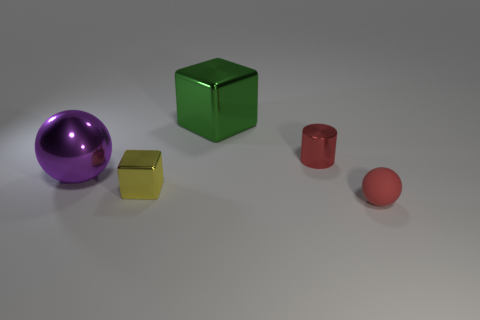Does the green cube have the same material as the ball that is on the left side of the big green shiny cube?
Ensure brevity in your answer.  Yes. What is the object that is both left of the green cube and behind the tiny yellow thing made of?
Your response must be concise. Metal. There is a block in front of the tiny red thing behind the red ball; what is its color?
Your answer should be compact. Yellow. There is a large thing on the left side of the big green object; what material is it?
Your answer should be very brief. Metal. Is the number of large metal objects less than the number of big blue blocks?
Your answer should be compact. No. There is a yellow object; is its shape the same as the red thing that is behind the small sphere?
Offer a very short reply. No. There is a metal object that is both in front of the tiny cylinder and to the right of the big purple sphere; what is its shape?
Ensure brevity in your answer.  Cube. Are there an equal number of tiny metal cylinders that are right of the red cylinder and red shiny objects that are to the left of the tiny yellow block?
Ensure brevity in your answer.  Yes. Is the shape of the matte thing in front of the small shiny cylinder the same as  the small yellow object?
Your answer should be very brief. No. How many purple objects are tiny matte balls or metallic spheres?
Ensure brevity in your answer.  1. 